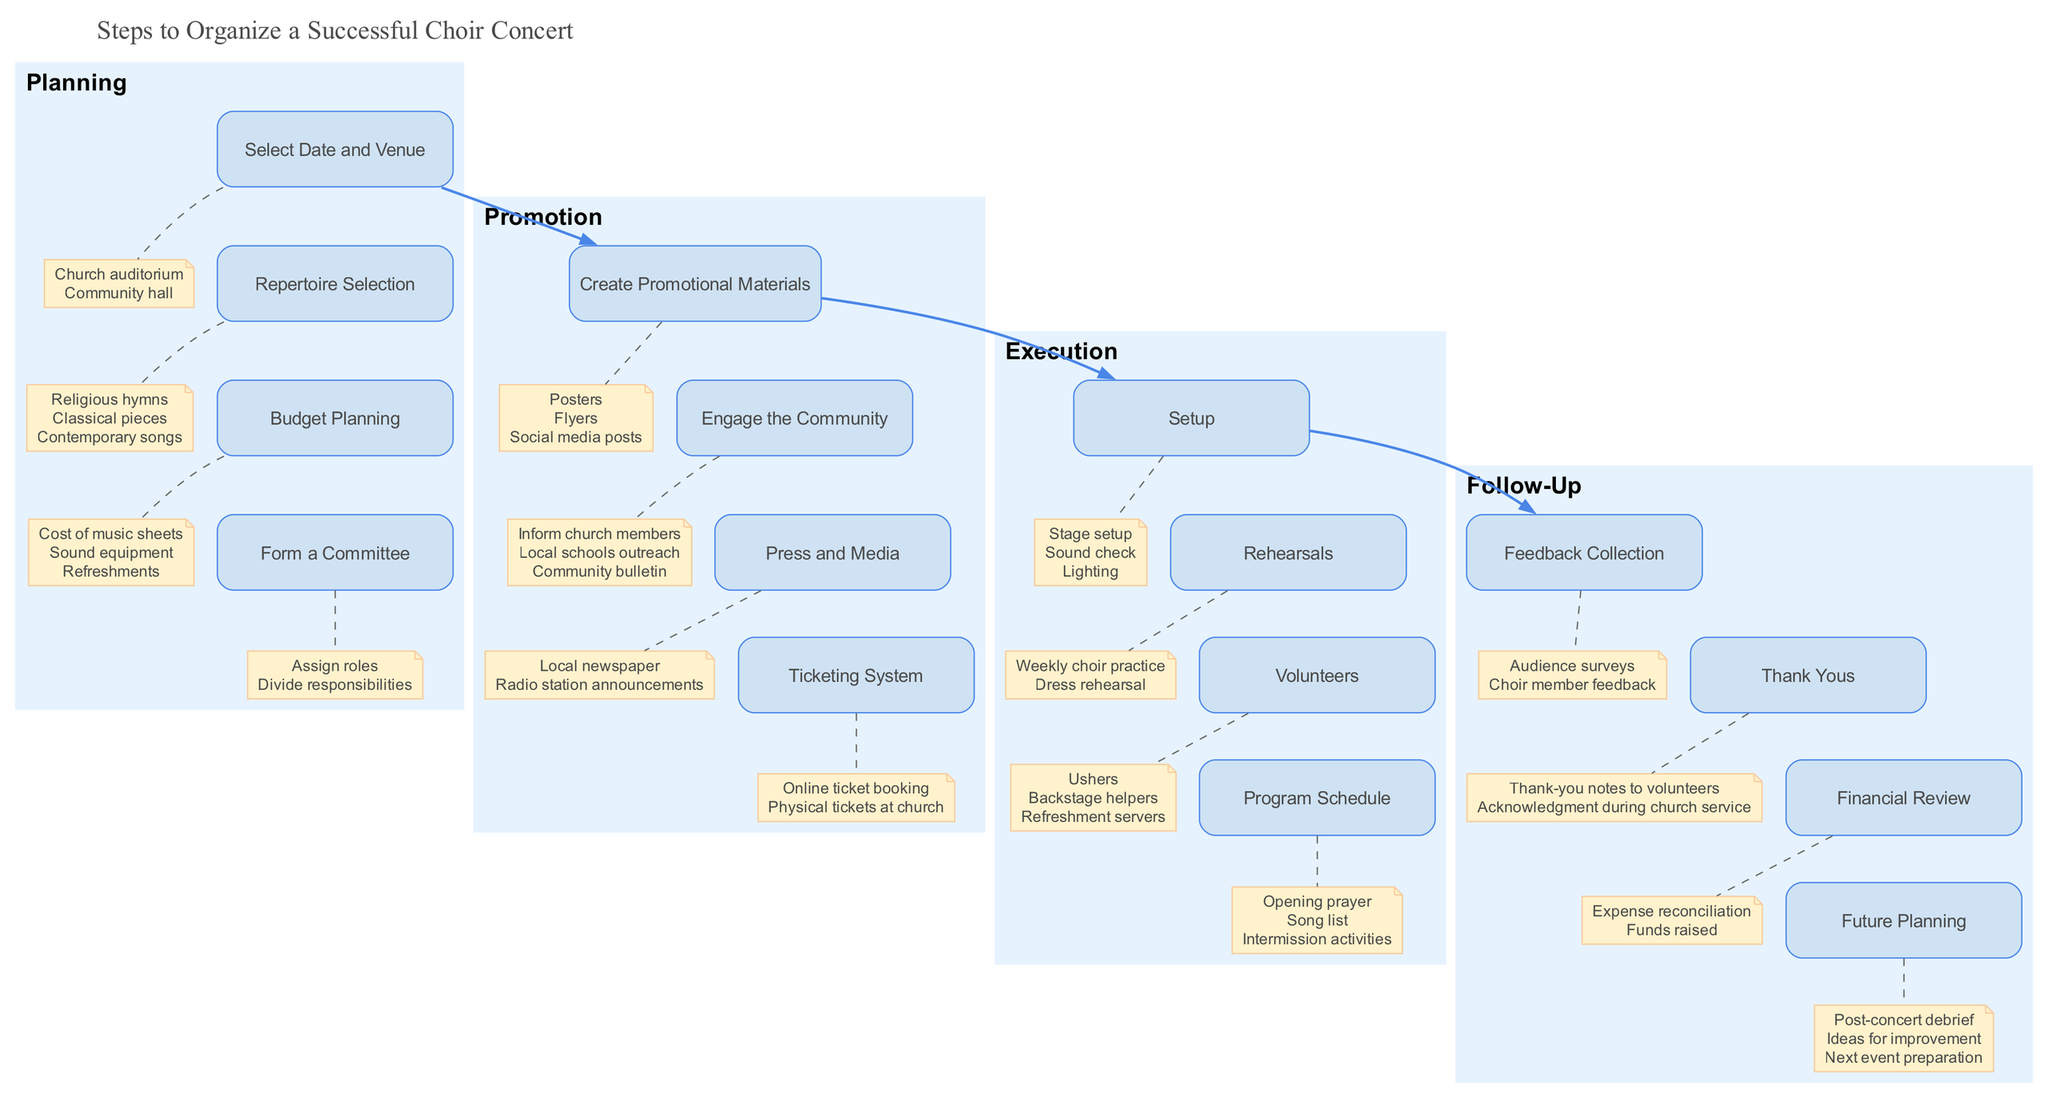What is the first step in the Planning category? The first step listed under the Planning category is "Select Date and Venue." This can be found as the first node in that category when examining the diagram.
Answer: Select Date and Venue How many steps are there in the Execution category? The Execution category contains four steps: "Setup", "Rehearsals", "Volunteers", and "Program Schedule." By counting the nodes within the Execution cluster, we find four items.
Answer: Four Which promotional material is suggested in the Promotion section? The Promotion section lists several items, and one of them is "Posters." This is clearly shown as one of the details under "Create Promotional Materials."
Answer: Posters What is the last step listed in the Follow-Up category? The last step in the Follow-Up category is "Future Planning." This is determined by identifying the order of steps listed in that category, with "Future Planning" being the last node.
Answer: Future Planning Which category contains the step "Program Schedule"? The "Program Schedule" step is found in the Execution category. By navigating through the edges and nodes, we can trace that it belongs to the Execution cluster.
Answer: Execution What type of materials are listed under the "Create Promotional Materials"? The materials listed under this step include "Posters," "Flyers," and "Social media posts." These are the details connected to the "Create Promotional Materials" node in the Promotion category.
Answer: Posters, Flyers, Social media posts How is "Thank Yous" related to the Follow-Up category? "Thank Yous" is one of the steps listed within the Follow-Up category. It directly falls under the main heading of Follow-Up and is connected to that category in the diagram.
Answer: Thank Yous What links the Planning category to the Promotion category? The main link connecting the Planning category to the Promotion category is a bold edge, indicating a sequential relationship between the two main process clusters in the diagram.
Answer: Bold edge What do we need to do after the concert according to the Follow-Up category? After the concert, according to the Follow-Up category, we need to engage in "Feedback Collection." This activity is listed as one of the steps to undertake after the concert.
Answer: Feedback Collection 